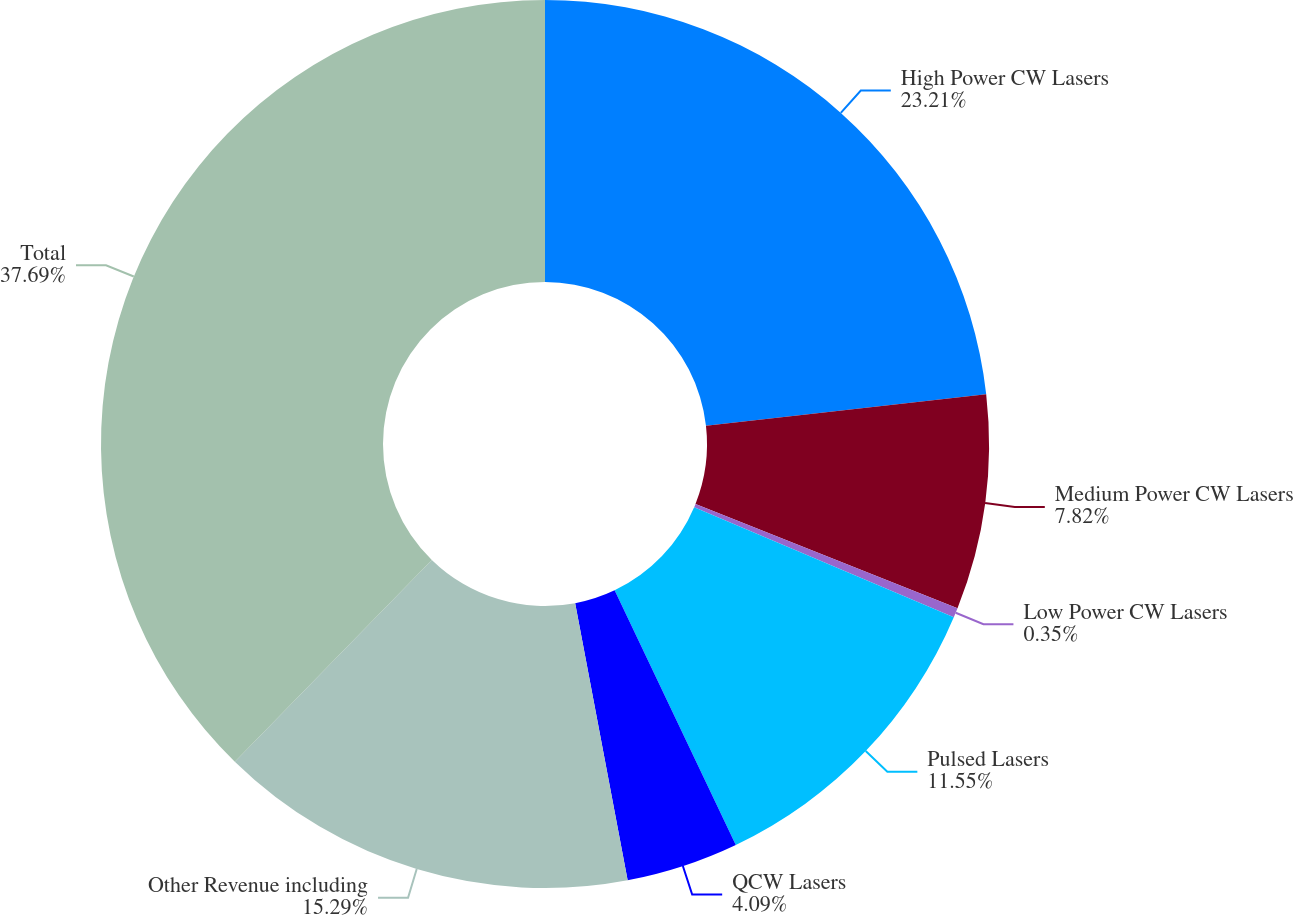<chart> <loc_0><loc_0><loc_500><loc_500><pie_chart><fcel>High Power CW Lasers<fcel>Medium Power CW Lasers<fcel>Low Power CW Lasers<fcel>Pulsed Lasers<fcel>QCW Lasers<fcel>Other Revenue including<fcel>Total<nl><fcel>23.21%<fcel>7.82%<fcel>0.35%<fcel>11.55%<fcel>4.09%<fcel>15.29%<fcel>37.69%<nl></chart> 